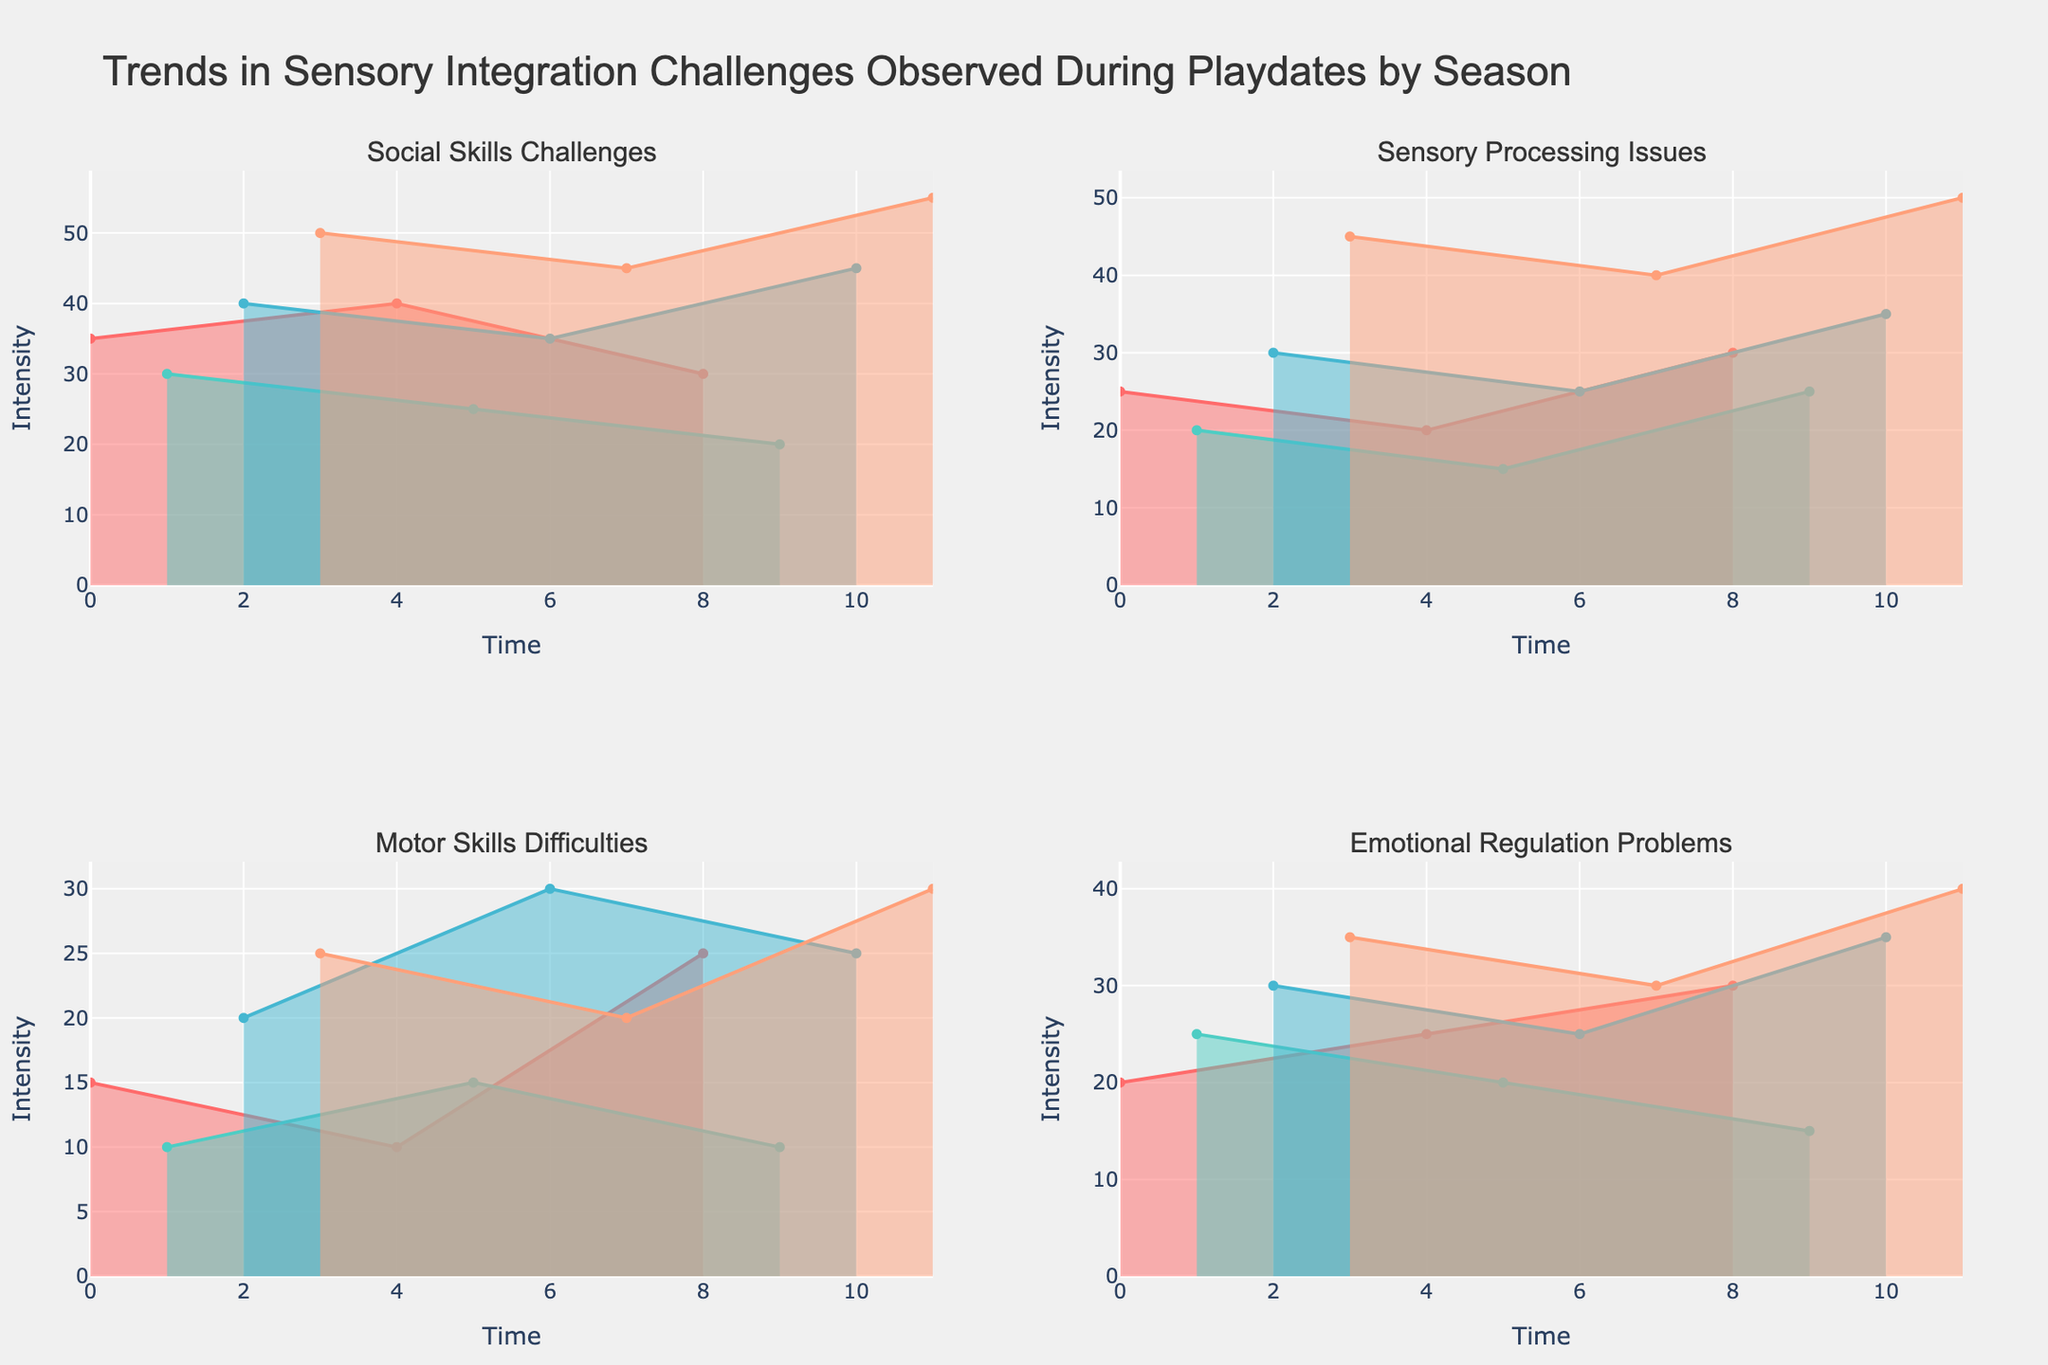What's the title of the figure? The title of the figure is displayed prominently at the top.
Answer: Trends in Sensory Integration Challenges Observed During Playdates by Season How many seasons are represented in the figure? The figure represents data divided by different seasons, which are labeled in the subplots.
Answer: Four Which season shows the highest intensity of Social Skills Challenges? To find the season with the highest intensity, look for the peak value in the subplot for Social Skills Challenges.
Answer: Winter What is the color used for representing Sensory Processing Issues? The subtype of challenges Sensory Processing Issues is assigned a unique color, visible in its specific subplot.
Answer: A teal or cyan-like color How do Spring and Summer compare in terms of Sensory Processing Issues? To compare Spring and Summer, look at their respective peaks in the subplot for Sensory Processing Issues and identify which has the higher value.
Answer: Spring is higher than Summer What is the average intensity of Motor Skills Difficulties during Autumn? Add the values of Motor Skills Difficulties for Autumn and divide by the number of occurrences. Calculation: (20 + 30 + 25) / 3 = 25
Answer: 25 Which challenge shows the most variation across seasons? Identify the challenge with the widest range between its highest and lowest values across the subplots.
Answer: Social Skills Challenges What is the trend for Emotional Regulation Problems from Spring to Winter? Note the intensities of Emotional Regulation Problems across each season and describe the overall trend. Spring: 20, Summer: 25, Autumn: 30, Winter: 35. The intensity generally increases every season.
Answer: Increasing trend During which season is there a peak in both Social Skills Challenges and Emotional Regulation Problems? Look for the season when both subplots for Social Skills Challenges and Emotional Regulation Problems show peak values.
Answer: Winter Which subplot shows a decrease from Autumn to Winter? Identify the subplot that displays lower intensity values in Winter compared to Autumn.
Answer: Motor Skills Difficulties 